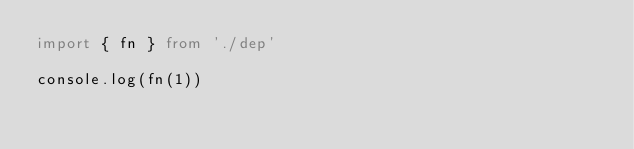Convert code to text. <code><loc_0><loc_0><loc_500><loc_500><_TypeScript_>import { fn } from './dep'

console.log(fn(1))
</code> 